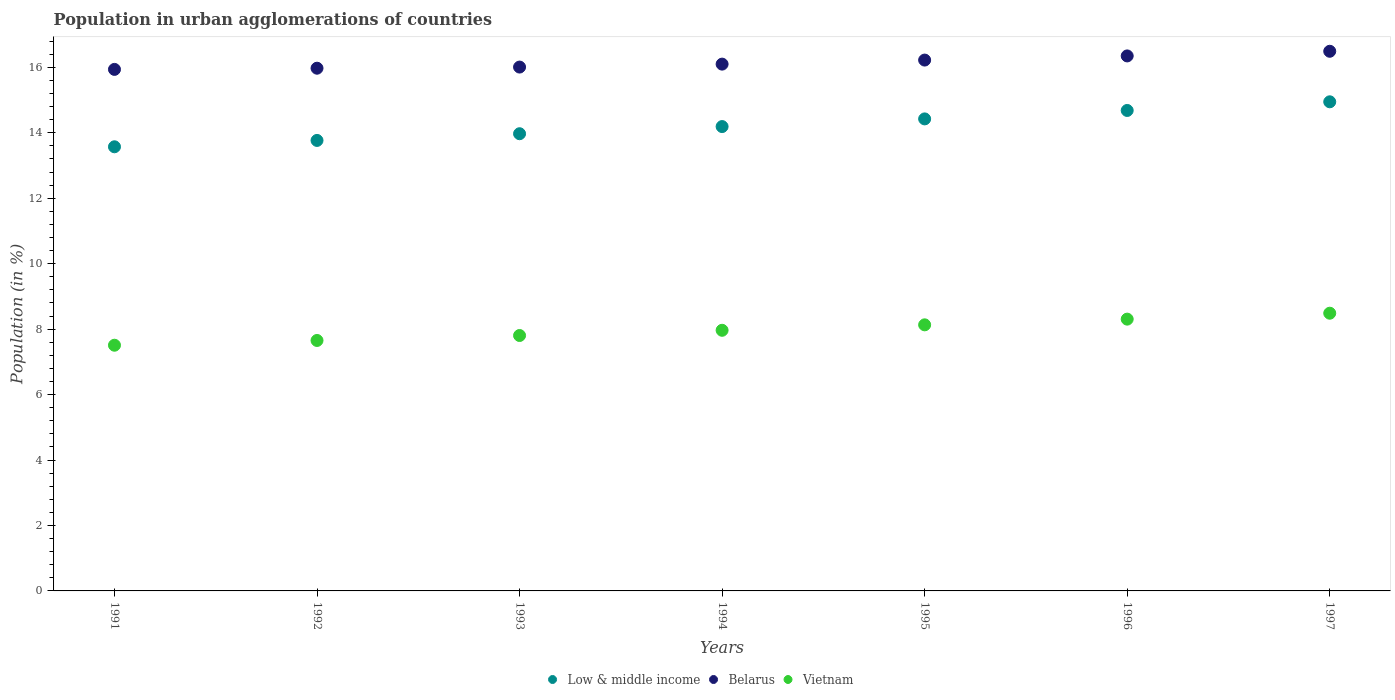How many different coloured dotlines are there?
Offer a very short reply. 3. Is the number of dotlines equal to the number of legend labels?
Give a very brief answer. Yes. What is the percentage of population in urban agglomerations in Low & middle income in 1993?
Provide a succinct answer. 13.97. Across all years, what is the maximum percentage of population in urban agglomerations in Low & middle income?
Your answer should be very brief. 14.95. Across all years, what is the minimum percentage of population in urban agglomerations in Belarus?
Offer a terse response. 15.94. In which year was the percentage of population in urban agglomerations in Belarus maximum?
Ensure brevity in your answer.  1997. What is the total percentage of population in urban agglomerations in Low & middle income in the graph?
Keep it short and to the point. 99.56. What is the difference between the percentage of population in urban agglomerations in Vietnam in 1993 and that in 1994?
Keep it short and to the point. -0.16. What is the difference between the percentage of population in urban agglomerations in Low & middle income in 1994 and the percentage of population in urban agglomerations in Vietnam in 1997?
Provide a short and direct response. 5.7. What is the average percentage of population in urban agglomerations in Low & middle income per year?
Provide a succinct answer. 14.22. In the year 1997, what is the difference between the percentage of population in urban agglomerations in Belarus and percentage of population in urban agglomerations in Low & middle income?
Keep it short and to the point. 1.54. What is the ratio of the percentage of population in urban agglomerations in Vietnam in 1993 to that in 1997?
Offer a terse response. 0.92. Is the percentage of population in urban agglomerations in Vietnam in 1991 less than that in 1995?
Give a very brief answer. Yes. What is the difference between the highest and the second highest percentage of population in urban agglomerations in Low & middle income?
Make the answer very short. 0.26. What is the difference between the highest and the lowest percentage of population in urban agglomerations in Belarus?
Give a very brief answer. 0.55. Does the percentage of population in urban agglomerations in Vietnam monotonically increase over the years?
Ensure brevity in your answer.  Yes. Is the percentage of population in urban agglomerations in Low & middle income strictly less than the percentage of population in urban agglomerations in Vietnam over the years?
Make the answer very short. No. Does the graph contain grids?
Ensure brevity in your answer.  No. What is the title of the graph?
Provide a short and direct response. Population in urban agglomerations of countries. Does "Lebanon" appear as one of the legend labels in the graph?
Make the answer very short. No. What is the label or title of the Y-axis?
Provide a succinct answer. Population (in %). What is the Population (in %) in Low & middle income in 1991?
Ensure brevity in your answer.  13.57. What is the Population (in %) of Belarus in 1991?
Your answer should be compact. 15.94. What is the Population (in %) of Vietnam in 1991?
Give a very brief answer. 7.51. What is the Population (in %) of Low & middle income in 1992?
Keep it short and to the point. 13.77. What is the Population (in %) of Belarus in 1992?
Your answer should be compact. 15.97. What is the Population (in %) in Vietnam in 1992?
Offer a very short reply. 7.65. What is the Population (in %) in Low & middle income in 1993?
Give a very brief answer. 13.97. What is the Population (in %) in Belarus in 1993?
Keep it short and to the point. 16.01. What is the Population (in %) in Vietnam in 1993?
Provide a short and direct response. 7.81. What is the Population (in %) in Low & middle income in 1994?
Your answer should be compact. 14.19. What is the Population (in %) of Belarus in 1994?
Offer a terse response. 16.1. What is the Population (in %) in Vietnam in 1994?
Offer a very short reply. 7.97. What is the Population (in %) in Low & middle income in 1995?
Your response must be concise. 14.43. What is the Population (in %) in Belarus in 1995?
Offer a terse response. 16.22. What is the Population (in %) in Vietnam in 1995?
Offer a very short reply. 8.13. What is the Population (in %) in Low & middle income in 1996?
Make the answer very short. 14.68. What is the Population (in %) in Belarus in 1996?
Keep it short and to the point. 16.35. What is the Population (in %) in Vietnam in 1996?
Ensure brevity in your answer.  8.31. What is the Population (in %) of Low & middle income in 1997?
Provide a short and direct response. 14.95. What is the Population (in %) of Belarus in 1997?
Make the answer very short. 16.49. What is the Population (in %) of Vietnam in 1997?
Give a very brief answer. 8.49. Across all years, what is the maximum Population (in %) in Low & middle income?
Your answer should be very brief. 14.95. Across all years, what is the maximum Population (in %) of Belarus?
Your answer should be very brief. 16.49. Across all years, what is the maximum Population (in %) in Vietnam?
Your answer should be very brief. 8.49. Across all years, what is the minimum Population (in %) in Low & middle income?
Keep it short and to the point. 13.57. Across all years, what is the minimum Population (in %) in Belarus?
Give a very brief answer. 15.94. Across all years, what is the minimum Population (in %) of Vietnam?
Your answer should be very brief. 7.51. What is the total Population (in %) of Low & middle income in the graph?
Your answer should be very brief. 99.56. What is the total Population (in %) in Belarus in the graph?
Your response must be concise. 113.08. What is the total Population (in %) of Vietnam in the graph?
Provide a short and direct response. 55.86. What is the difference between the Population (in %) of Low & middle income in 1991 and that in 1992?
Make the answer very short. -0.19. What is the difference between the Population (in %) of Belarus in 1991 and that in 1992?
Ensure brevity in your answer.  -0.04. What is the difference between the Population (in %) of Vietnam in 1991 and that in 1992?
Provide a succinct answer. -0.15. What is the difference between the Population (in %) in Low & middle income in 1991 and that in 1993?
Your answer should be very brief. -0.4. What is the difference between the Population (in %) of Belarus in 1991 and that in 1993?
Your answer should be very brief. -0.07. What is the difference between the Population (in %) in Vietnam in 1991 and that in 1993?
Ensure brevity in your answer.  -0.3. What is the difference between the Population (in %) in Low & middle income in 1991 and that in 1994?
Provide a short and direct response. -0.62. What is the difference between the Population (in %) of Belarus in 1991 and that in 1994?
Make the answer very short. -0.16. What is the difference between the Population (in %) of Vietnam in 1991 and that in 1994?
Provide a succinct answer. -0.46. What is the difference between the Population (in %) in Low & middle income in 1991 and that in 1995?
Offer a terse response. -0.85. What is the difference between the Population (in %) of Belarus in 1991 and that in 1995?
Offer a very short reply. -0.28. What is the difference between the Population (in %) of Vietnam in 1991 and that in 1995?
Offer a very short reply. -0.62. What is the difference between the Population (in %) of Low & middle income in 1991 and that in 1996?
Keep it short and to the point. -1.11. What is the difference between the Population (in %) of Belarus in 1991 and that in 1996?
Ensure brevity in your answer.  -0.41. What is the difference between the Population (in %) of Vietnam in 1991 and that in 1996?
Provide a succinct answer. -0.8. What is the difference between the Population (in %) in Low & middle income in 1991 and that in 1997?
Your answer should be compact. -1.37. What is the difference between the Population (in %) in Belarus in 1991 and that in 1997?
Your answer should be very brief. -0.55. What is the difference between the Population (in %) of Vietnam in 1991 and that in 1997?
Provide a short and direct response. -0.98. What is the difference between the Population (in %) in Low & middle income in 1992 and that in 1993?
Make the answer very short. -0.2. What is the difference between the Population (in %) of Belarus in 1992 and that in 1993?
Give a very brief answer. -0.03. What is the difference between the Population (in %) of Vietnam in 1992 and that in 1993?
Offer a very short reply. -0.15. What is the difference between the Population (in %) in Low & middle income in 1992 and that in 1994?
Your answer should be very brief. -0.42. What is the difference between the Population (in %) in Belarus in 1992 and that in 1994?
Ensure brevity in your answer.  -0.12. What is the difference between the Population (in %) of Vietnam in 1992 and that in 1994?
Provide a short and direct response. -0.31. What is the difference between the Population (in %) of Low & middle income in 1992 and that in 1995?
Your answer should be compact. -0.66. What is the difference between the Population (in %) in Belarus in 1992 and that in 1995?
Offer a terse response. -0.25. What is the difference between the Population (in %) of Vietnam in 1992 and that in 1995?
Offer a very short reply. -0.48. What is the difference between the Population (in %) in Low & middle income in 1992 and that in 1996?
Provide a short and direct response. -0.92. What is the difference between the Population (in %) of Belarus in 1992 and that in 1996?
Your response must be concise. -0.38. What is the difference between the Population (in %) of Vietnam in 1992 and that in 1996?
Your answer should be compact. -0.65. What is the difference between the Population (in %) of Low & middle income in 1992 and that in 1997?
Provide a short and direct response. -1.18. What is the difference between the Population (in %) of Belarus in 1992 and that in 1997?
Provide a short and direct response. -0.52. What is the difference between the Population (in %) of Vietnam in 1992 and that in 1997?
Your response must be concise. -0.83. What is the difference between the Population (in %) in Low & middle income in 1993 and that in 1994?
Your answer should be compact. -0.22. What is the difference between the Population (in %) of Belarus in 1993 and that in 1994?
Offer a terse response. -0.09. What is the difference between the Population (in %) of Vietnam in 1993 and that in 1994?
Your response must be concise. -0.16. What is the difference between the Population (in %) in Low & middle income in 1993 and that in 1995?
Offer a terse response. -0.45. What is the difference between the Population (in %) of Belarus in 1993 and that in 1995?
Your response must be concise. -0.21. What is the difference between the Population (in %) in Vietnam in 1993 and that in 1995?
Offer a terse response. -0.33. What is the difference between the Population (in %) of Low & middle income in 1993 and that in 1996?
Offer a terse response. -0.71. What is the difference between the Population (in %) in Belarus in 1993 and that in 1996?
Provide a short and direct response. -0.34. What is the difference between the Population (in %) in Vietnam in 1993 and that in 1996?
Give a very brief answer. -0.5. What is the difference between the Population (in %) in Low & middle income in 1993 and that in 1997?
Make the answer very short. -0.98. What is the difference between the Population (in %) in Belarus in 1993 and that in 1997?
Provide a succinct answer. -0.48. What is the difference between the Population (in %) in Vietnam in 1993 and that in 1997?
Give a very brief answer. -0.68. What is the difference between the Population (in %) of Low & middle income in 1994 and that in 1995?
Give a very brief answer. -0.23. What is the difference between the Population (in %) of Belarus in 1994 and that in 1995?
Your answer should be compact. -0.12. What is the difference between the Population (in %) of Vietnam in 1994 and that in 1995?
Offer a very short reply. -0.17. What is the difference between the Population (in %) of Low & middle income in 1994 and that in 1996?
Ensure brevity in your answer.  -0.49. What is the difference between the Population (in %) of Belarus in 1994 and that in 1996?
Your response must be concise. -0.25. What is the difference between the Population (in %) of Vietnam in 1994 and that in 1996?
Keep it short and to the point. -0.34. What is the difference between the Population (in %) of Low & middle income in 1994 and that in 1997?
Offer a very short reply. -0.76. What is the difference between the Population (in %) in Belarus in 1994 and that in 1997?
Your answer should be compact. -0.39. What is the difference between the Population (in %) of Vietnam in 1994 and that in 1997?
Provide a succinct answer. -0.52. What is the difference between the Population (in %) in Low & middle income in 1995 and that in 1996?
Make the answer very short. -0.26. What is the difference between the Population (in %) of Belarus in 1995 and that in 1996?
Make the answer very short. -0.13. What is the difference between the Population (in %) of Vietnam in 1995 and that in 1996?
Your response must be concise. -0.17. What is the difference between the Population (in %) in Low & middle income in 1995 and that in 1997?
Your answer should be compact. -0.52. What is the difference between the Population (in %) of Belarus in 1995 and that in 1997?
Ensure brevity in your answer.  -0.27. What is the difference between the Population (in %) of Vietnam in 1995 and that in 1997?
Offer a terse response. -0.36. What is the difference between the Population (in %) in Low & middle income in 1996 and that in 1997?
Give a very brief answer. -0.26. What is the difference between the Population (in %) in Belarus in 1996 and that in 1997?
Make the answer very short. -0.14. What is the difference between the Population (in %) of Vietnam in 1996 and that in 1997?
Provide a succinct answer. -0.18. What is the difference between the Population (in %) in Low & middle income in 1991 and the Population (in %) in Belarus in 1992?
Your answer should be very brief. -2.4. What is the difference between the Population (in %) of Low & middle income in 1991 and the Population (in %) of Vietnam in 1992?
Provide a short and direct response. 5.92. What is the difference between the Population (in %) in Belarus in 1991 and the Population (in %) in Vietnam in 1992?
Keep it short and to the point. 8.28. What is the difference between the Population (in %) of Low & middle income in 1991 and the Population (in %) of Belarus in 1993?
Ensure brevity in your answer.  -2.44. What is the difference between the Population (in %) of Low & middle income in 1991 and the Population (in %) of Vietnam in 1993?
Offer a very short reply. 5.77. What is the difference between the Population (in %) of Belarus in 1991 and the Population (in %) of Vietnam in 1993?
Offer a very short reply. 8.13. What is the difference between the Population (in %) of Low & middle income in 1991 and the Population (in %) of Belarus in 1994?
Your response must be concise. -2.53. What is the difference between the Population (in %) of Low & middle income in 1991 and the Population (in %) of Vietnam in 1994?
Your response must be concise. 5.61. What is the difference between the Population (in %) of Belarus in 1991 and the Population (in %) of Vietnam in 1994?
Make the answer very short. 7.97. What is the difference between the Population (in %) in Low & middle income in 1991 and the Population (in %) in Belarus in 1995?
Ensure brevity in your answer.  -2.65. What is the difference between the Population (in %) of Low & middle income in 1991 and the Population (in %) of Vietnam in 1995?
Offer a very short reply. 5.44. What is the difference between the Population (in %) of Belarus in 1991 and the Population (in %) of Vietnam in 1995?
Your answer should be very brief. 7.81. What is the difference between the Population (in %) of Low & middle income in 1991 and the Population (in %) of Belarus in 1996?
Provide a short and direct response. -2.78. What is the difference between the Population (in %) in Low & middle income in 1991 and the Population (in %) in Vietnam in 1996?
Offer a terse response. 5.27. What is the difference between the Population (in %) of Belarus in 1991 and the Population (in %) of Vietnam in 1996?
Make the answer very short. 7.63. What is the difference between the Population (in %) in Low & middle income in 1991 and the Population (in %) in Belarus in 1997?
Provide a succinct answer. -2.92. What is the difference between the Population (in %) of Low & middle income in 1991 and the Population (in %) of Vietnam in 1997?
Provide a succinct answer. 5.09. What is the difference between the Population (in %) of Belarus in 1991 and the Population (in %) of Vietnam in 1997?
Keep it short and to the point. 7.45. What is the difference between the Population (in %) of Low & middle income in 1992 and the Population (in %) of Belarus in 1993?
Your response must be concise. -2.24. What is the difference between the Population (in %) in Low & middle income in 1992 and the Population (in %) in Vietnam in 1993?
Offer a very short reply. 5.96. What is the difference between the Population (in %) in Belarus in 1992 and the Population (in %) in Vietnam in 1993?
Provide a succinct answer. 8.17. What is the difference between the Population (in %) in Low & middle income in 1992 and the Population (in %) in Belarus in 1994?
Give a very brief answer. -2.33. What is the difference between the Population (in %) in Low & middle income in 1992 and the Population (in %) in Vietnam in 1994?
Keep it short and to the point. 5.8. What is the difference between the Population (in %) in Belarus in 1992 and the Population (in %) in Vietnam in 1994?
Give a very brief answer. 8.01. What is the difference between the Population (in %) in Low & middle income in 1992 and the Population (in %) in Belarus in 1995?
Give a very brief answer. -2.46. What is the difference between the Population (in %) in Low & middle income in 1992 and the Population (in %) in Vietnam in 1995?
Ensure brevity in your answer.  5.64. What is the difference between the Population (in %) of Belarus in 1992 and the Population (in %) of Vietnam in 1995?
Provide a short and direct response. 7.84. What is the difference between the Population (in %) of Low & middle income in 1992 and the Population (in %) of Belarus in 1996?
Your answer should be compact. -2.58. What is the difference between the Population (in %) of Low & middle income in 1992 and the Population (in %) of Vietnam in 1996?
Give a very brief answer. 5.46. What is the difference between the Population (in %) in Belarus in 1992 and the Population (in %) in Vietnam in 1996?
Offer a terse response. 7.67. What is the difference between the Population (in %) of Low & middle income in 1992 and the Population (in %) of Belarus in 1997?
Give a very brief answer. -2.72. What is the difference between the Population (in %) in Low & middle income in 1992 and the Population (in %) in Vietnam in 1997?
Make the answer very short. 5.28. What is the difference between the Population (in %) in Belarus in 1992 and the Population (in %) in Vietnam in 1997?
Offer a very short reply. 7.49. What is the difference between the Population (in %) in Low & middle income in 1993 and the Population (in %) in Belarus in 1994?
Provide a succinct answer. -2.13. What is the difference between the Population (in %) of Low & middle income in 1993 and the Population (in %) of Vietnam in 1994?
Your answer should be very brief. 6.01. What is the difference between the Population (in %) of Belarus in 1993 and the Population (in %) of Vietnam in 1994?
Keep it short and to the point. 8.04. What is the difference between the Population (in %) in Low & middle income in 1993 and the Population (in %) in Belarus in 1995?
Your response must be concise. -2.25. What is the difference between the Population (in %) of Low & middle income in 1993 and the Population (in %) of Vietnam in 1995?
Make the answer very short. 5.84. What is the difference between the Population (in %) in Belarus in 1993 and the Population (in %) in Vietnam in 1995?
Offer a very short reply. 7.88. What is the difference between the Population (in %) in Low & middle income in 1993 and the Population (in %) in Belarus in 1996?
Offer a terse response. -2.38. What is the difference between the Population (in %) of Low & middle income in 1993 and the Population (in %) of Vietnam in 1996?
Your answer should be compact. 5.67. What is the difference between the Population (in %) of Belarus in 1993 and the Population (in %) of Vietnam in 1996?
Keep it short and to the point. 7.7. What is the difference between the Population (in %) of Low & middle income in 1993 and the Population (in %) of Belarus in 1997?
Ensure brevity in your answer.  -2.52. What is the difference between the Population (in %) of Low & middle income in 1993 and the Population (in %) of Vietnam in 1997?
Provide a succinct answer. 5.49. What is the difference between the Population (in %) in Belarus in 1993 and the Population (in %) in Vietnam in 1997?
Give a very brief answer. 7.52. What is the difference between the Population (in %) of Low & middle income in 1994 and the Population (in %) of Belarus in 1995?
Ensure brevity in your answer.  -2.03. What is the difference between the Population (in %) of Low & middle income in 1994 and the Population (in %) of Vietnam in 1995?
Ensure brevity in your answer.  6.06. What is the difference between the Population (in %) of Belarus in 1994 and the Population (in %) of Vietnam in 1995?
Your response must be concise. 7.97. What is the difference between the Population (in %) in Low & middle income in 1994 and the Population (in %) in Belarus in 1996?
Ensure brevity in your answer.  -2.16. What is the difference between the Population (in %) in Low & middle income in 1994 and the Population (in %) in Vietnam in 1996?
Your answer should be compact. 5.88. What is the difference between the Population (in %) of Belarus in 1994 and the Population (in %) of Vietnam in 1996?
Ensure brevity in your answer.  7.79. What is the difference between the Population (in %) in Low & middle income in 1994 and the Population (in %) in Belarus in 1997?
Your answer should be compact. -2.3. What is the difference between the Population (in %) of Low & middle income in 1994 and the Population (in %) of Vietnam in 1997?
Provide a succinct answer. 5.7. What is the difference between the Population (in %) of Belarus in 1994 and the Population (in %) of Vietnam in 1997?
Your response must be concise. 7.61. What is the difference between the Population (in %) in Low & middle income in 1995 and the Population (in %) in Belarus in 1996?
Ensure brevity in your answer.  -1.92. What is the difference between the Population (in %) of Low & middle income in 1995 and the Population (in %) of Vietnam in 1996?
Ensure brevity in your answer.  6.12. What is the difference between the Population (in %) of Belarus in 1995 and the Population (in %) of Vietnam in 1996?
Ensure brevity in your answer.  7.92. What is the difference between the Population (in %) of Low & middle income in 1995 and the Population (in %) of Belarus in 1997?
Give a very brief answer. -2.07. What is the difference between the Population (in %) in Low & middle income in 1995 and the Population (in %) in Vietnam in 1997?
Your answer should be very brief. 5.94. What is the difference between the Population (in %) of Belarus in 1995 and the Population (in %) of Vietnam in 1997?
Provide a short and direct response. 7.74. What is the difference between the Population (in %) of Low & middle income in 1996 and the Population (in %) of Belarus in 1997?
Your answer should be compact. -1.81. What is the difference between the Population (in %) of Low & middle income in 1996 and the Population (in %) of Vietnam in 1997?
Keep it short and to the point. 6.2. What is the difference between the Population (in %) in Belarus in 1996 and the Population (in %) in Vietnam in 1997?
Your answer should be very brief. 7.86. What is the average Population (in %) in Low & middle income per year?
Keep it short and to the point. 14.22. What is the average Population (in %) of Belarus per year?
Make the answer very short. 16.16. What is the average Population (in %) in Vietnam per year?
Offer a terse response. 7.98. In the year 1991, what is the difference between the Population (in %) in Low & middle income and Population (in %) in Belarus?
Offer a terse response. -2.37. In the year 1991, what is the difference between the Population (in %) in Low & middle income and Population (in %) in Vietnam?
Your answer should be very brief. 6.06. In the year 1991, what is the difference between the Population (in %) of Belarus and Population (in %) of Vietnam?
Your answer should be very brief. 8.43. In the year 1992, what is the difference between the Population (in %) of Low & middle income and Population (in %) of Belarus?
Ensure brevity in your answer.  -2.21. In the year 1992, what is the difference between the Population (in %) of Low & middle income and Population (in %) of Vietnam?
Your response must be concise. 6.11. In the year 1992, what is the difference between the Population (in %) of Belarus and Population (in %) of Vietnam?
Provide a succinct answer. 8.32. In the year 1993, what is the difference between the Population (in %) in Low & middle income and Population (in %) in Belarus?
Provide a succinct answer. -2.04. In the year 1993, what is the difference between the Population (in %) in Low & middle income and Population (in %) in Vietnam?
Provide a succinct answer. 6.17. In the year 1993, what is the difference between the Population (in %) in Belarus and Population (in %) in Vietnam?
Offer a terse response. 8.2. In the year 1994, what is the difference between the Population (in %) of Low & middle income and Population (in %) of Belarus?
Offer a terse response. -1.91. In the year 1994, what is the difference between the Population (in %) of Low & middle income and Population (in %) of Vietnam?
Offer a terse response. 6.23. In the year 1994, what is the difference between the Population (in %) in Belarus and Population (in %) in Vietnam?
Your response must be concise. 8.13. In the year 1995, what is the difference between the Population (in %) in Low & middle income and Population (in %) in Belarus?
Give a very brief answer. -1.8. In the year 1995, what is the difference between the Population (in %) of Low & middle income and Population (in %) of Vietnam?
Keep it short and to the point. 6.29. In the year 1995, what is the difference between the Population (in %) of Belarus and Population (in %) of Vietnam?
Give a very brief answer. 8.09. In the year 1996, what is the difference between the Population (in %) in Low & middle income and Population (in %) in Belarus?
Your answer should be compact. -1.67. In the year 1996, what is the difference between the Population (in %) in Low & middle income and Population (in %) in Vietnam?
Your response must be concise. 6.38. In the year 1996, what is the difference between the Population (in %) in Belarus and Population (in %) in Vietnam?
Your answer should be very brief. 8.04. In the year 1997, what is the difference between the Population (in %) of Low & middle income and Population (in %) of Belarus?
Provide a short and direct response. -1.54. In the year 1997, what is the difference between the Population (in %) of Low & middle income and Population (in %) of Vietnam?
Your answer should be compact. 6.46. In the year 1997, what is the difference between the Population (in %) of Belarus and Population (in %) of Vietnam?
Keep it short and to the point. 8. What is the ratio of the Population (in %) of Low & middle income in 1991 to that in 1992?
Offer a terse response. 0.99. What is the ratio of the Population (in %) of Vietnam in 1991 to that in 1992?
Give a very brief answer. 0.98. What is the ratio of the Population (in %) in Low & middle income in 1991 to that in 1993?
Offer a very short reply. 0.97. What is the ratio of the Population (in %) of Belarus in 1991 to that in 1993?
Offer a terse response. 1. What is the ratio of the Population (in %) in Vietnam in 1991 to that in 1993?
Ensure brevity in your answer.  0.96. What is the ratio of the Population (in %) in Low & middle income in 1991 to that in 1994?
Your answer should be very brief. 0.96. What is the ratio of the Population (in %) in Belarus in 1991 to that in 1994?
Ensure brevity in your answer.  0.99. What is the ratio of the Population (in %) of Vietnam in 1991 to that in 1994?
Provide a short and direct response. 0.94. What is the ratio of the Population (in %) of Low & middle income in 1991 to that in 1995?
Keep it short and to the point. 0.94. What is the ratio of the Population (in %) in Belarus in 1991 to that in 1995?
Offer a terse response. 0.98. What is the ratio of the Population (in %) of Vietnam in 1991 to that in 1995?
Provide a succinct answer. 0.92. What is the ratio of the Population (in %) of Low & middle income in 1991 to that in 1996?
Provide a short and direct response. 0.92. What is the ratio of the Population (in %) of Belarus in 1991 to that in 1996?
Provide a short and direct response. 0.97. What is the ratio of the Population (in %) in Vietnam in 1991 to that in 1996?
Give a very brief answer. 0.9. What is the ratio of the Population (in %) of Low & middle income in 1991 to that in 1997?
Your response must be concise. 0.91. What is the ratio of the Population (in %) of Belarus in 1991 to that in 1997?
Your answer should be very brief. 0.97. What is the ratio of the Population (in %) of Vietnam in 1991 to that in 1997?
Ensure brevity in your answer.  0.88. What is the ratio of the Population (in %) of Low & middle income in 1992 to that in 1993?
Ensure brevity in your answer.  0.99. What is the ratio of the Population (in %) in Belarus in 1992 to that in 1993?
Ensure brevity in your answer.  1. What is the ratio of the Population (in %) of Vietnam in 1992 to that in 1993?
Give a very brief answer. 0.98. What is the ratio of the Population (in %) in Low & middle income in 1992 to that in 1994?
Offer a terse response. 0.97. What is the ratio of the Population (in %) of Belarus in 1992 to that in 1994?
Ensure brevity in your answer.  0.99. What is the ratio of the Population (in %) of Vietnam in 1992 to that in 1994?
Offer a very short reply. 0.96. What is the ratio of the Population (in %) of Low & middle income in 1992 to that in 1995?
Offer a very short reply. 0.95. What is the ratio of the Population (in %) of Belarus in 1992 to that in 1995?
Ensure brevity in your answer.  0.98. What is the ratio of the Population (in %) in Vietnam in 1992 to that in 1995?
Your response must be concise. 0.94. What is the ratio of the Population (in %) of Low & middle income in 1992 to that in 1996?
Your response must be concise. 0.94. What is the ratio of the Population (in %) of Belarus in 1992 to that in 1996?
Provide a succinct answer. 0.98. What is the ratio of the Population (in %) of Vietnam in 1992 to that in 1996?
Ensure brevity in your answer.  0.92. What is the ratio of the Population (in %) in Low & middle income in 1992 to that in 1997?
Your response must be concise. 0.92. What is the ratio of the Population (in %) of Belarus in 1992 to that in 1997?
Keep it short and to the point. 0.97. What is the ratio of the Population (in %) of Vietnam in 1992 to that in 1997?
Keep it short and to the point. 0.9. What is the ratio of the Population (in %) of Low & middle income in 1993 to that in 1994?
Offer a very short reply. 0.98. What is the ratio of the Population (in %) in Belarus in 1993 to that in 1994?
Your answer should be very brief. 0.99. What is the ratio of the Population (in %) of Vietnam in 1993 to that in 1994?
Offer a very short reply. 0.98. What is the ratio of the Population (in %) of Low & middle income in 1993 to that in 1995?
Your response must be concise. 0.97. What is the ratio of the Population (in %) in Vietnam in 1993 to that in 1995?
Provide a short and direct response. 0.96. What is the ratio of the Population (in %) in Low & middle income in 1993 to that in 1996?
Your response must be concise. 0.95. What is the ratio of the Population (in %) in Belarus in 1993 to that in 1996?
Ensure brevity in your answer.  0.98. What is the ratio of the Population (in %) in Vietnam in 1993 to that in 1996?
Make the answer very short. 0.94. What is the ratio of the Population (in %) of Low & middle income in 1993 to that in 1997?
Your response must be concise. 0.93. What is the ratio of the Population (in %) of Belarus in 1993 to that in 1997?
Keep it short and to the point. 0.97. What is the ratio of the Population (in %) of Vietnam in 1993 to that in 1997?
Offer a terse response. 0.92. What is the ratio of the Population (in %) of Low & middle income in 1994 to that in 1995?
Offer a terse response. 0.98. What is the ratio of the Population (in %) in Belarus in 1994 to that in 1995?
Offer a very short reply. 0.99. What is the ratio of the Population (in %) of Vietnam in 1994 to that in 1995?
Offer a very short reply. 0.98. What is the ratio of the Population (in %) in Low & middle income in 1994 to that in 1996?
Make the answer very short. 0.97. What is the ratio of the Population (in %) of Belarus in 1994 to that in 1996?
Provide a short and direct response. 0.98. What is the ratio of the Population (in %) in Low & middle income in 1994 to that in 1997?
Make the answer very short. 0.95. What is the ratio of the Population (in %) of Belarus in 1994 to that in 1997?
Provide a short and direct response. 0.98. What is the ratio of the Population (in %) in Vietnam in 1994 to that in 1997?
Your answer should be very brief. 0.94. What is the ratio of the Population (in %) in Low & middle income in 1995 to that in 1996?
Make the answer very short. 0.98. What is the ratio of the Population (in %) in Vietnam in 1995 to that in 1996?
Offer a terse response. 0.98. What is the ratio of the Population (in %) in Low & middle income in 1995 to that in 1997?
Provide a succinct answer. 0.97. What is the ratio of the Population (in %) of Belarus in 1995 to that in 1997?
Ensure brevity in your answer.  0.98. What is the ratio of the Population (in %) in Vietnam in 1995 to that in 1997?
Provide a succinct answer. 0.96. What is the ratio of the Population (in %) of Low & middle income in 1996 to that in 1997?
Your answer should be very brief. 0.98. What is the ratio of the Population (in %) in Vietnam in 1996 to that in 1997?
Offer a very short reply. 0.98. What is the difference between the highest and the second highest Population (in %) in Low & middle income?
Your answer should be compact. 0.26. What is the difference between the highest and the second highest Population (in %) of Belarus?
Give a very brief answer. 0.14. What is the difference between the highest and the second highest Population (in %) of Vietnam?
Provide a short and direct response. 0.18. What is the difference between the highest and the lowest Population (in %) of Low & middle income?
Provide a succinct answer. 1.37. What is the difference between the highest and the lowest Population (in %) of Belarus?
Offer a terse response. 0.55. What is the difference between the highest and the lowest Population (in %) in Vietnam?
Provide a short and direct response. 0.98. 